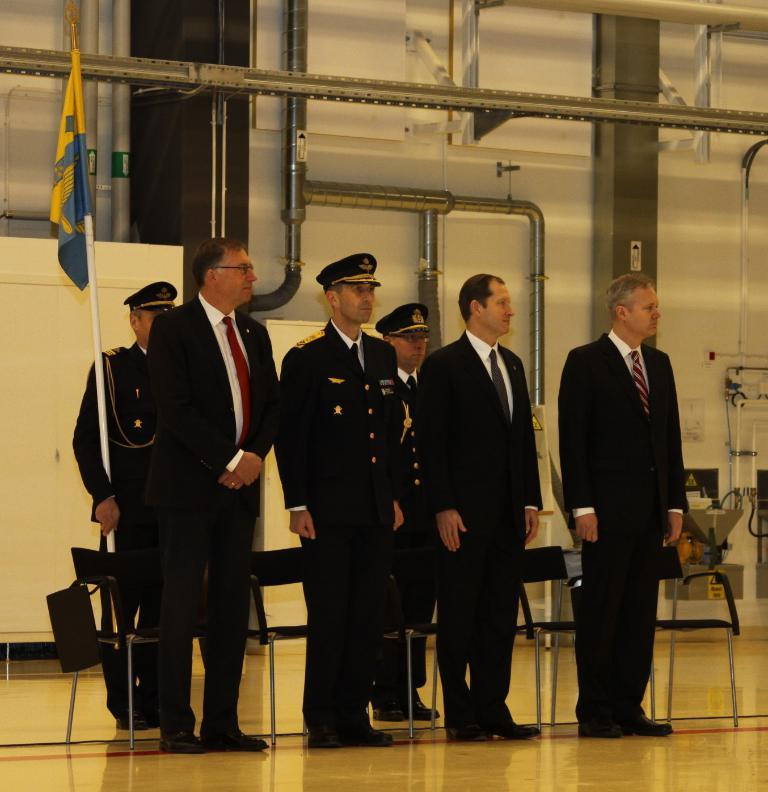What are the people in the image doing? The people in the image are standing. What is the person holding in the image? One person is holding a flag. What type of material are the rods made of in the image? The rods in the image are made of metal. What are the poles used for in the image? The poles are likely used for support or as part of a structure. What type of furniture is present in the image? There are chairs in the image. Can you describe any other objects present in the image? There are other objects present in the image, but their specific details are not mentioned in the provided facts. What type of music is being played by the group of ducks in the image? There are no ducks or music present in the image. 